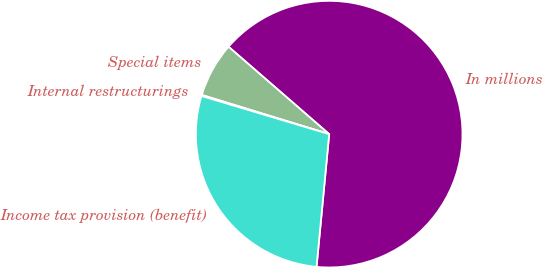Convert chart to OTSL. <chart><loc_0><loc_0><loc_500><loc_500><pie_chart><fcel>In millions<fcel>Special items<fcel>Internal restructurings<fcel>Income tax provision (benefit)<nl><fcel>65.13%<fcel>6.63%<fcel>0.13%<fcel>28.11%<nl></chart> 